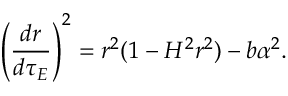Convert formula to latex. <formula><loc_0><loc_0><loc_500><loc_500>\left ( \frac { d r } { d \tau _ { E } } \right ) ^ { 2 } = r ^ { 2 } ( 1 - H ^ { 2 } r ^ { 2 } ) - b \alpha ^ { 2 } .</formula> 